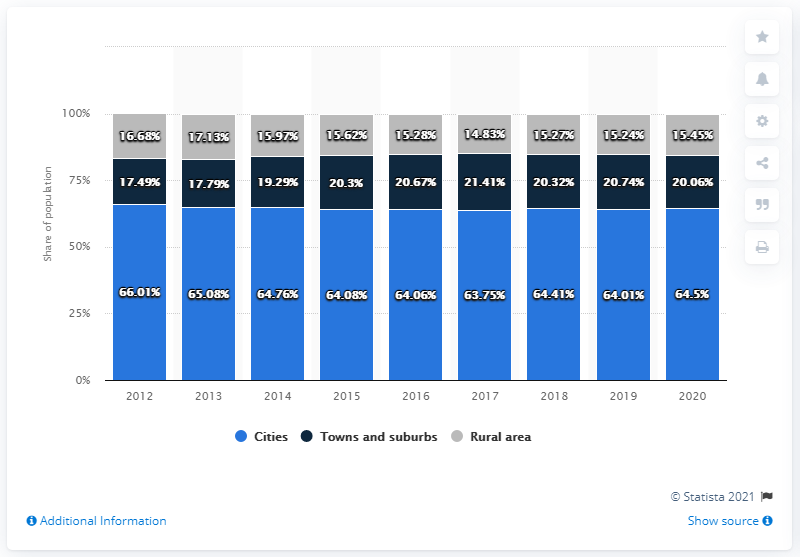Outline some significant characteristics in this image. In 2020, it was estimated that 15.45% of Iceland's population lived in thinly populated areas. 